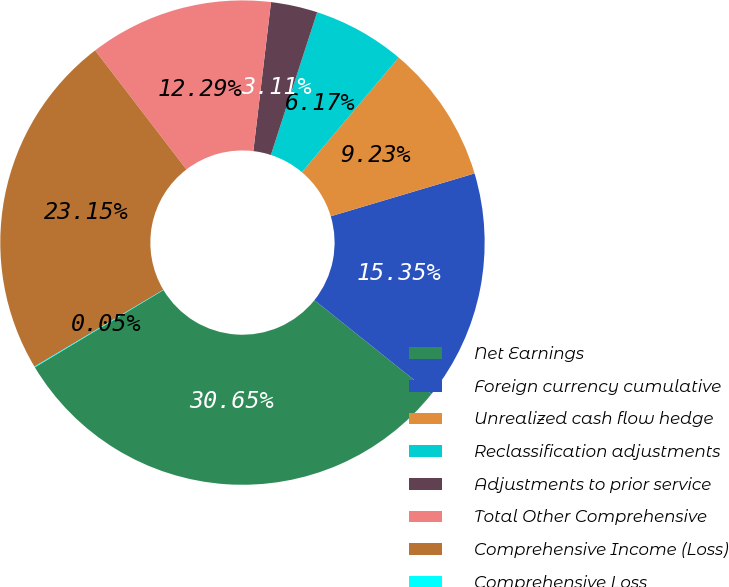Convert chart to OTSL. <chart><loc_0><loc_0><loc_500><loc_500><pie_chart><fcel>Net Earnings<fcel>Foreign currency cumulative<fcel>Unrealized cash flow hedge<fcel>Reclassification adjustments<fcel>Adjustments to prior service<fcel>Total Other Comprehensive<fcel>Comprehensive Income (Loss)<fcel>Comprehensive Loss<nl><fcel>30.65%<fcel>15.35%<fcel>9.23%<fcel>6.17%<fcel>3.11%<fcel>12.29%<fcel>23.15%<fcel>0.05%<nl></chart> 